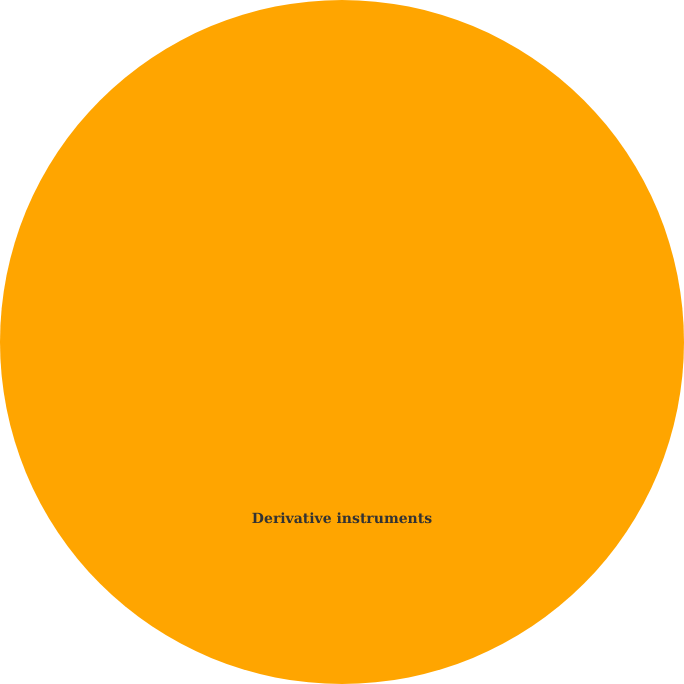<chart> <loc_0><loc_0><loc_500><loc_500><pie_chart><fcel>Derivative instruments<nl><fcel>100.0%<nl></chart> 